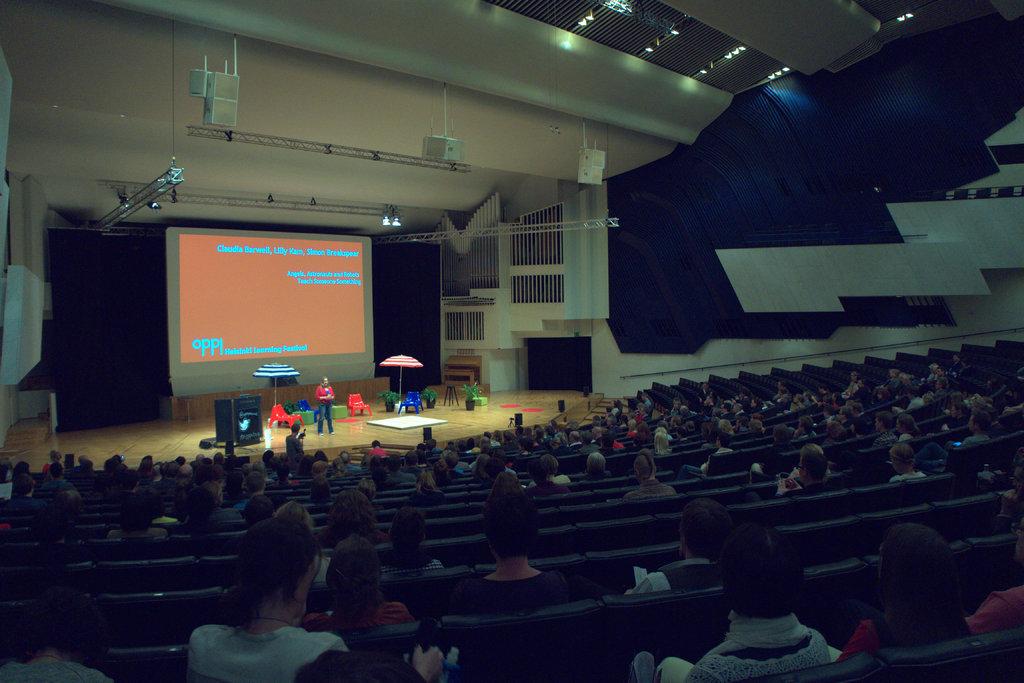4 big letters in the bottom left of this powerpoint?
Keep it short and to the point. Oppl. What is the first person's name listed on the top?
Keep it short and to the point. Claudia. 